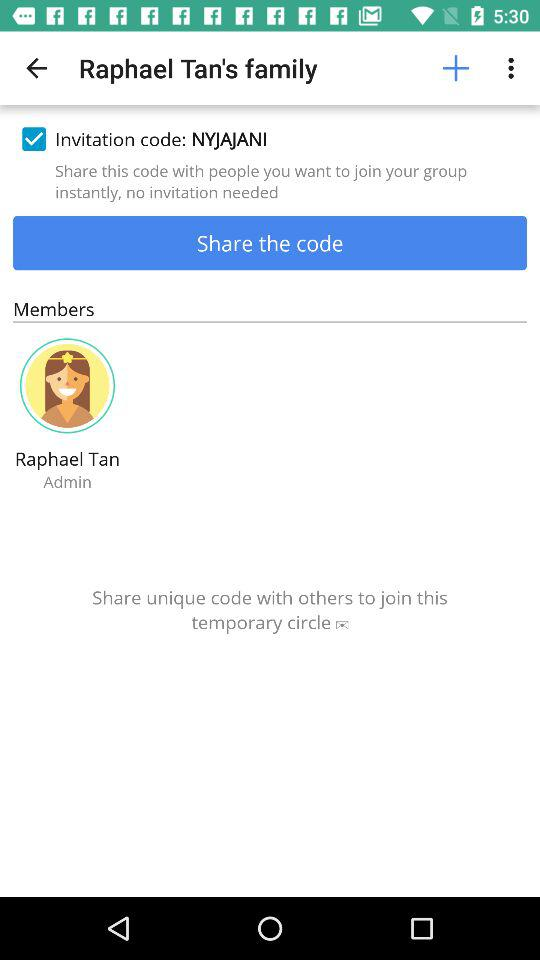What is the invitation code? The invitation code is "NYJAJANI". 